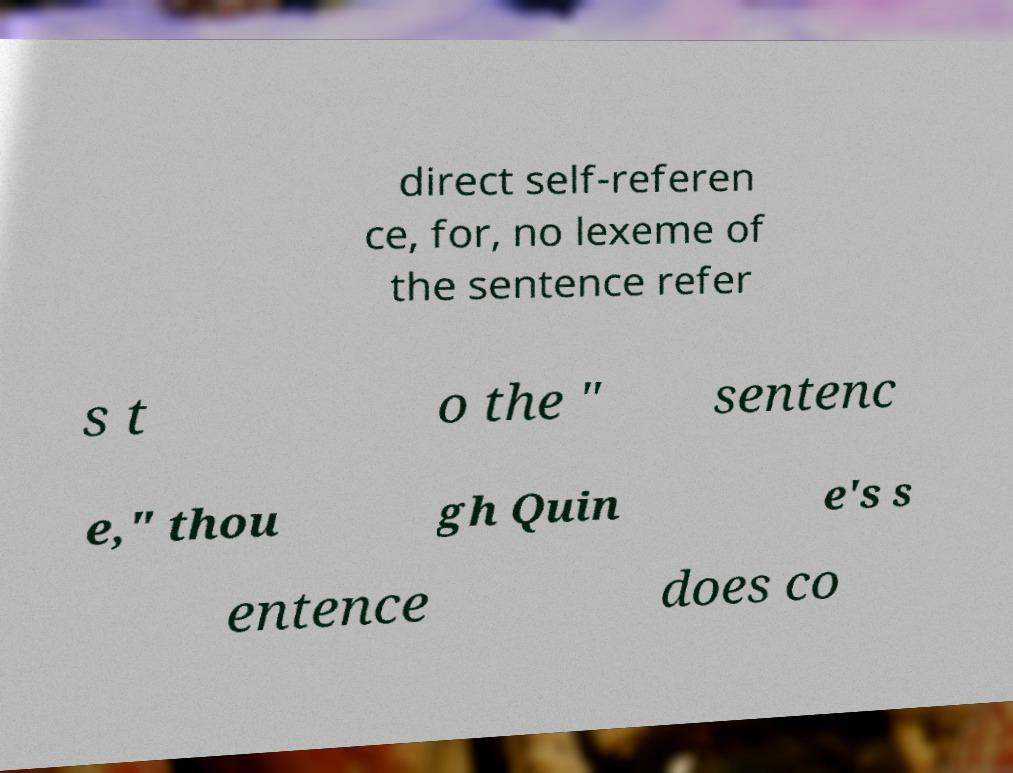Could you extract and type out the text from this image? direct self-referen ce, for, no lexeme of the sentence refer s t o the " sentenc e," thou gh Quin e's s entence does co 